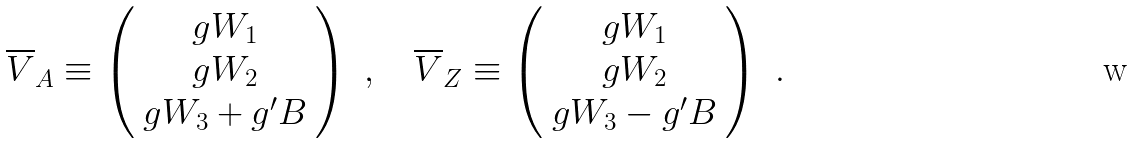<formula> <loc_0><loc_0><loc_500><loc_500>\overline { V } _ { A } \equiv \left ( \begin{array} { c } g W _ { 1 } \\ g W _ { 2 } \\ g W _ { 3 } + g ^ { \prime } B \end{array} \right ) \ , \quad \overline { V } _ { Z } \equiv \left ( \begin{array} { c } g W _ { 1 } \\ g W _ { 2 } \\ g W _ { 3 } - g ^ { \prime } B \end{array} \right ) \ .</formula> 